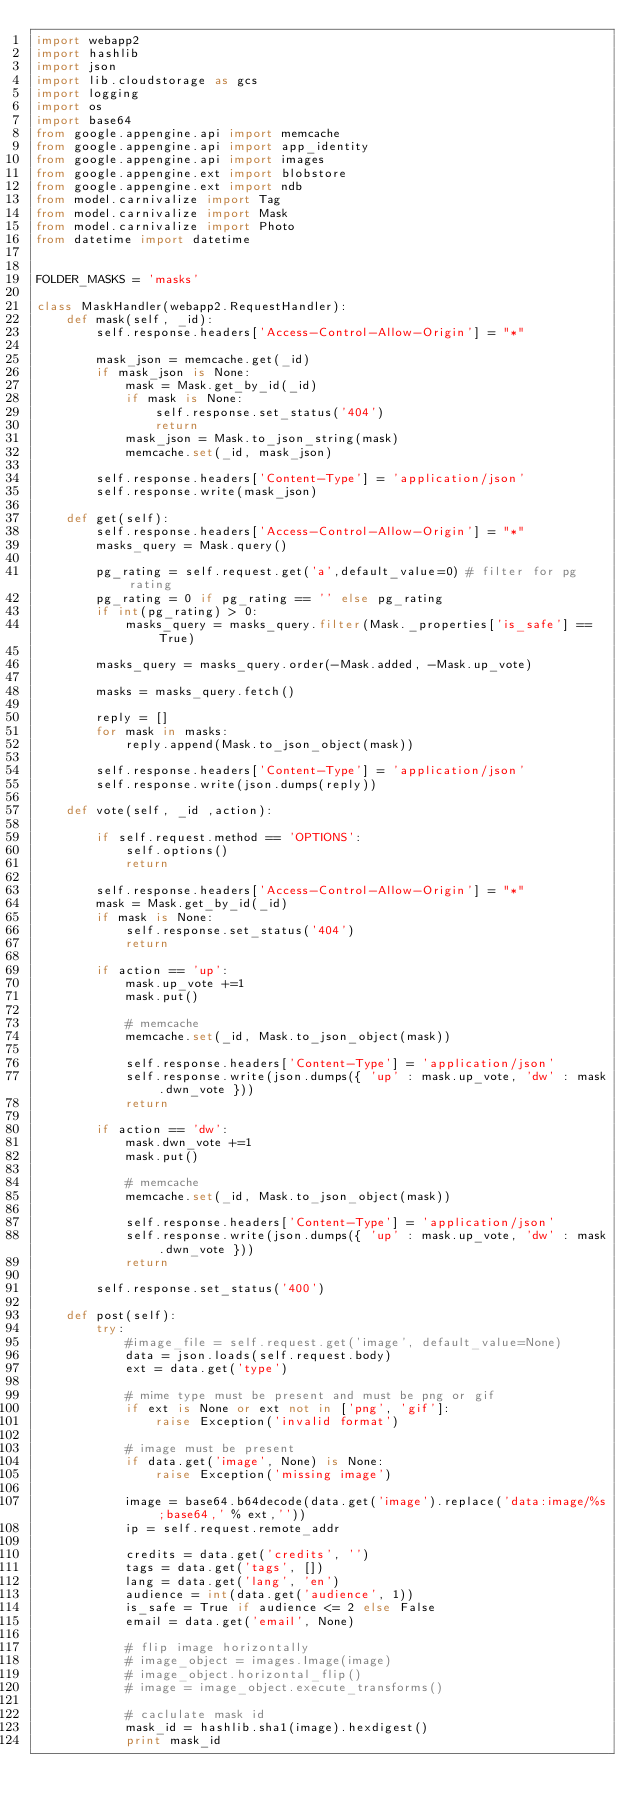<code> <loc_0><loc_0><loc_500><loc_500><_Python_>import webapp2
import hashlib
import json
import lib.cloudstorage as gcs
import logging
import os
import base64
from google.appengine.api import memcache
from google.appengine.api import app_identity
from google.appengine.api import images
from google.appengine.ext import blobstore
from google.appengine.ext import ndb
from model.carnivalize import Tag
from model.carnivalize import Mask
from model.carnivalize import Photo
from datetime import datetime


FOLDER_MASKS = 'masks'

class MaskHandler(webapp2.RequestHandler):
    def mask(self, _id):
        self.response.headers['Access-Control-Allow-Origin'] = "*"

        mask_json = memcache.get(_id)
        if mask_json is None:
            mask = Mask.get_by_id(_id)
            if mask is None:
                self.response.set_status('404')
                return
            mask_json = Mask.to_json_string(mask)
            memcache.set(_id, mask_json)

        self.response.headers['Content-Type'] = 'application/json'
        self.response.write(mask_json)

    def get(self):
        self.response.headers['Access-Control-Allow-Origin'] = "*"
        masks_query = Mask.query()

        pg_rating = self.request.get('a',default_value=0) # filter for pg rating
        pg_rating = 0 if pg_rating == '' else pg_rating
        if int(pg_rating) > 0:
            masks_query = masks_query.filter(Mask._properties['is_safe'] == True)
        
        masks_query = masks_query.order(-Mask.added, -Mask.up_vote)

        masks = masks_query.fetch()

        reply = []
        for mask in masks:
            reply.append(Mask.to_json_object(mask))

        self.response.headers['Content-Type'] = 'application/json'
        self.response.write(json.dumps(reply))   

    def vote(self, _id ,action):

        if self.request.method == 'OPTIONS':
            self.options()
            return

        self.response.headers['Access-Control-Allow-Origin'] = "*"
        mask = Mask.get_by_id(_id)
        if mask is None:
            self.response.set_status('404')
            return 

        if action == 'up':
            mask.up_vote +=1 
            mask.put()

            # memcache
            memcache.set(_id, Mask.to_json_object(mask))

            self.response.headers['Content-Type'] = 'application/json'
            self.response.write(json.dumps({ 'up' : mask.up_vote, 'dw' : mask.dwn_vote }))
            return

        if action == 'dw':
            mask.dwn_vote +=1
            mask.put()

            # memcache
            memcache.set(_id, Mask.to_json_object(mask))

            self.response.headers['Content-Type'] = 'application/json'
            self.response.write(json.dumps({ 'up' : mask.up_vote, 'dw' : mask.dwn_vote }))
            return 

        self.response.set_status('400')

    def post(self):
        try:
            #image_file = self.request.get('image', default_value=None)
            data = json.loads(self.request.body)
            ext = data.get('type')

            # mime type must be present and must be png or gif
            if ext is None or ext not in ['png', 'gif']:
                raise Exception('invalid format')

            # image must be present
            if data.get('image', None) is None:
                raise Exception('missing image')

            image = base64.b64decode(data.get('image').replace('data:image/%s;base64,' % ext,''))
            ip = self.request.remote_addr

            credits = data.get('credits', '')
            tags = data.get('tags', [])
            lang = data.get('lang', 'en')
            audience = int(data.get('audience', 1))
            is_safe = True if audience <= 2 else False
            email = data.get('email', None)
            
            # flip image horizontally
            # image_object = images.Image(image)
            # image_object.horizontal_flip()
            # image = image_object.execute_transforms()

            # caclulate mask id
            mask_id = hashlib.sha1(image).hexdigest()
            print mask_id
</code> 